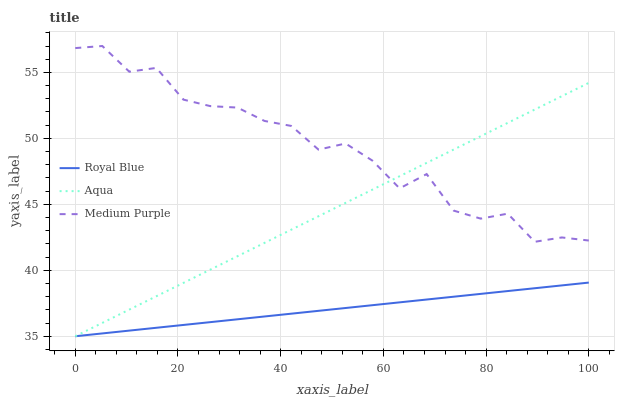Does Royal Blue have the minimum area under the curve?
Answer yes or no. Yes. Does Medium Purple have the maximum area under the curve?
Answer yes or no. Yes. Does Aqua have the minimum area under the curve?
Answer yes or no. No. Does Aqua have the maximum area under the curve?
Answer yes or no. No. Is Aqua the smoothest?
Answer yes or no. Yes. Is Medium Purple the roughest?
Answer yes or no. Yes. Is Royal Blue the smoothest?
Answer yes or no. No. Is Royal Blue the roughest?
Answer yes or no. No. Does Royal Blue have the lowest value?
Answer yes or no. Yes. Does Medium Purple have the highest value?
Answer yes or no. Yes. Does Aqua have the highest value?
Answer yes or no. No. Is Royal Blue less than Medium Purple?
Answer yes or no. Yes. Is Medium Purple greater than Royal Blue?
Answer yes or no. Yes. Does Aqua intersect Royal Blue?
Answer yes or no. Yes. Is Aqua less than Royal Blue?
Answer yes or no. No. Is Aqua greater than Royal Blue?
Answer yes or no. No. Does Royal Blue intersect Medium Purple?
Answer yes or no. No. 